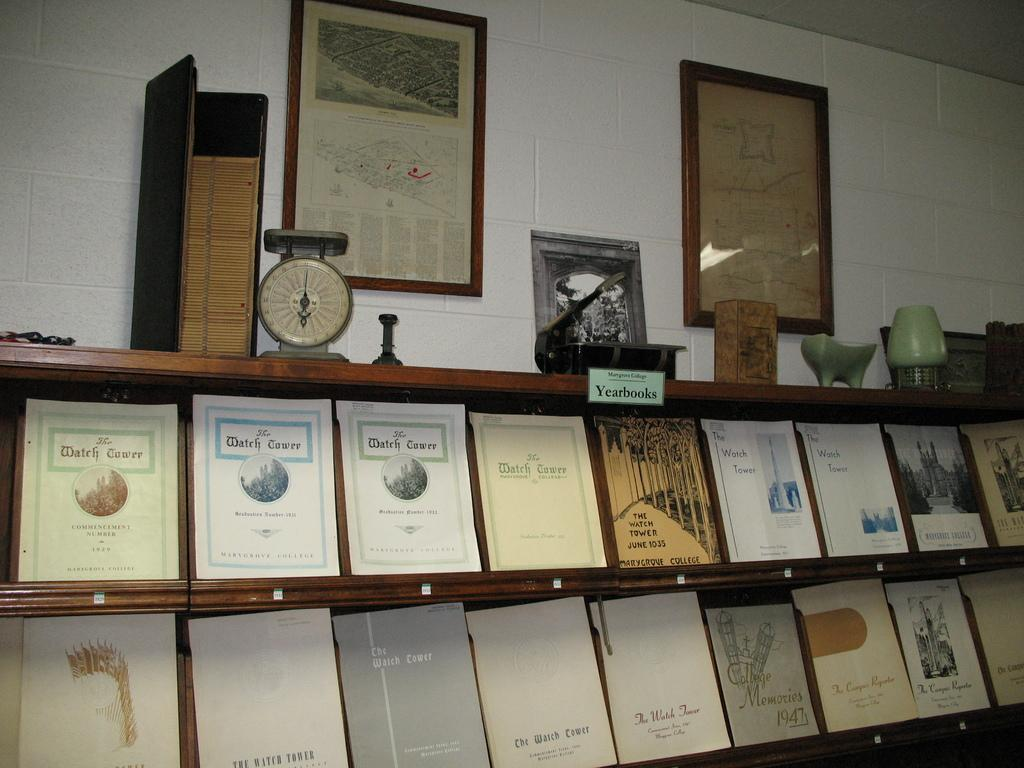What can be seen on the shelves in the image? There are shelves with books in the image. Are there any other items on the shelves besides books? Yes, there are other objects on the shelves. What can be seen on the wall in the background of the image? There are photo frames on the wall in the background of the image. What type of ice can be seen melting on the floor in the image? There is no ice present in the image; it features shelves with books and other objects, as well as photo frames on the wall. 